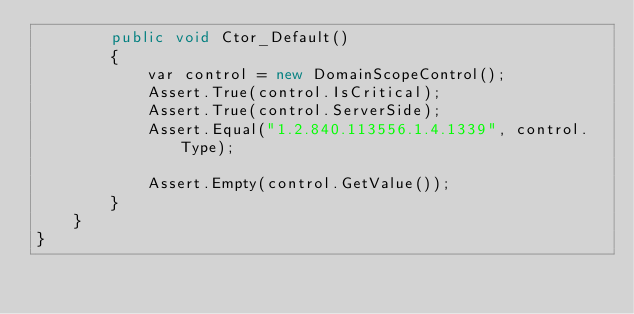Convert code to text. <code><loc_0><loc_0><loc_500><loc_500><_C#_>        public void Ctor_Default()
        {
            var control = new DomainScopeControl();
            Assert.True(control.IsCritical);
            Assert.True(control.ServerSide);
            Assert.Equal("1.2.840.113556.1.4.1339", control.Type);

            Assert.Empty(control.GetValue());
        }
    }
}
</code> 